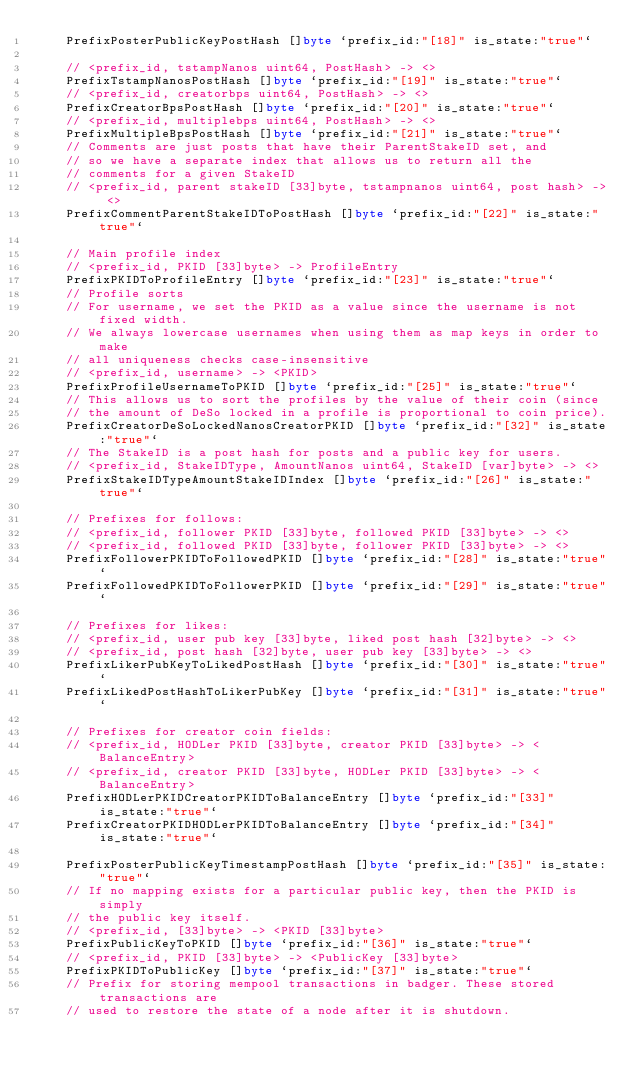<code> <loc_0><loc_0><loc_500><loc_500><_Go_>	PrefixPosterPublicKeyPostHash []byte `prefix_id:"[18]" is_state:"true"`

	// <prefix_id, tstampNanos uint64, PostHash> -> <>
	PrefixTstampNanosPostHash []byte `prefix_id:"[19]" is_state:"true"`
	// <prefix_id, creatorbps uint64, PostHash> -> <>
	PrefixCreatorBpsPostHash []byte `prefix_id:"[20]" is_state:"true"`
	// <prefix_id, multiplebps uint64, PostHash> -> <>
	PrefixMultipleBpsPostHash []byte `prefix_id:"[21]" is_state:"true"`
	// Comments are just posts that have their ParentStakeID set, and
	// so we have a separate index that allows us to return all the
	// comments for a given StakeID
	// <prefix_id, parent stakeID [33]byte, tstampnanos uint64, post hash> -> <>
	PrefixCommentParentStakeIDToPostHash []byte `prefix_id:"[22]" is_state:"true"`

	// Main profile index
	// <prefix_id, PKID [33]byte> -> ProfileEntry
	PrefixPKIDToProfileEntry []byte `prefix_id:"[23]" is_state:"true"`
	// Profile sorts
	// For username, we set the PKID as a value since the username is not fixed width.
	// We always lowercase usernames when using them as map keys in order to make
	// all uniqueness checks case-insensitive
	// <prefix_id, username> -> <PKID>
	PrefixProfileUsernameToPKID []byte `prefix_id:"[25]" is_state:"true"`
	// This allows us to sort the profiles by the value of their coin (since
	// the amount of DeSo locked in a profile is proportional to coin price).
	PrefixCreatorDeSoLockedNanosCreatorPKID []byte `prefix_id:"[32]" is_state:"true"`
	// The StakeID is a post hash for posts and a public key for users.
	// <prefix_id, StakeIDType, AmountNanos uint64, StakeID [var]byte> -> <>
	PrefixStakeIDTypeAmountStakeIDIndex []byte `prefix_id:"[26]" is_state:"true"`

	// Prefixes for follows:
	// <prefix_id, follower PKID [33]byte, followed PKID [33]byte> -> <>
	// <prefix_id, followed PKID [33]byte, follower PKID [33]byte> -> <>
	PrefixFollowerPKIDToFollowedPKID []byte `prefix_id:"[28]" is_state:"true"`
	PrefixFollowedPKIDToFollowerPKID []byte `prefix_id:"[29]" is_state:"true"`

	// Prefixes for likes:
	// <prefix_id, user pub key [33]byte, liked post hash [32]byte> -> <>
	// <prefix_id, post hash [32]byte, user pub key [33]byte> -> <>
	PrefixLikerPubKeyToLikedPostHash []byte `prefix_id:"[30]" is_state:"true"`
	PrefixLikedPostHashToLikerPubKey []byte `prefix_id:"[31]" is_state:"true"`

	// Prefixes for creator coin fields:
	// <prefix_id, HODLer PKID [33]byte, creator PKID [33]byte> -> <BalanceEntry>
	// <prefix_id, creator PKID [33]byte, HODLer PKID [33]byte> -> <BalanceEntry>
	PrefixHODLerPKIDCreatorPKIDToBalanceEntry []byte `prefix_id:"[33]" is_state:"true"`
	PrefixCreatorPKIDHODLerPKIDToBalanceEntry []byte `prefix_id:"[34]" is_state:"true"`

	PrefixPosterPublicKeyTimestampPostHash []byte `prefix_id:"[35]" is_state:"true"`
	// If no mapping exists for a particular public key, then the PKID is simply
	// the public key itself.
	// <prefix_id, [33]byte> -> <PKID [33]byte>
	PrefixPublicKeyToPKID []byte `prefix_id:"[36]" is_state:"true"`
	// <prefix_id, PKID [33]byte> -> <PublicKey [33]byte>
	PrefixPKIDToPublicKey []byte `prefix_id:"[37]" is_state:"true"`
	// Prefix for storing mempool transactions in badger. These stored transactions are
	// used to restore the state of a node after it is shutdown.</code> 